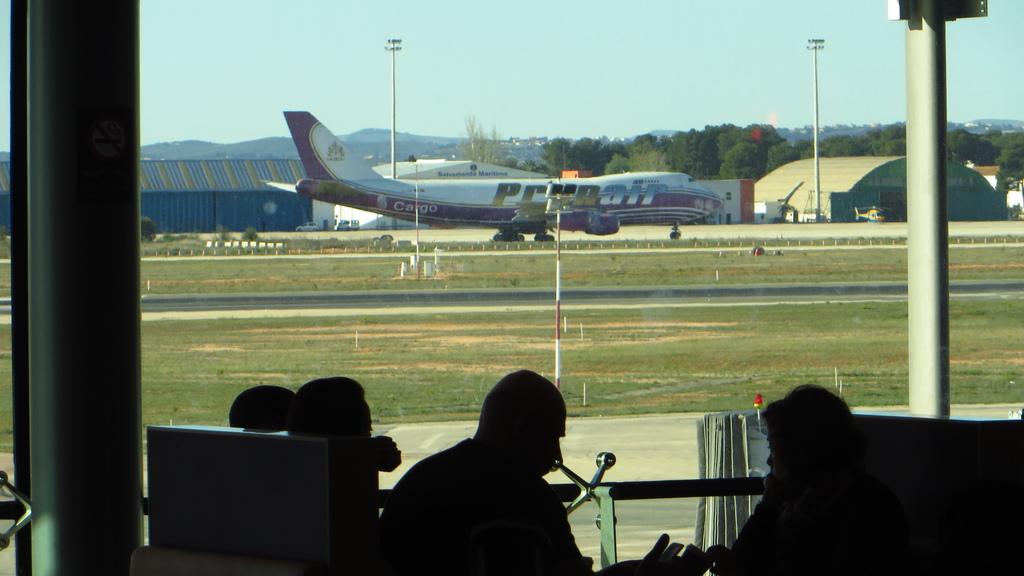What airline does the plane belong to?
Ensure brevity in your answer.  Prya air. What does the plan carry?
Your response must be concise. Cargo. 